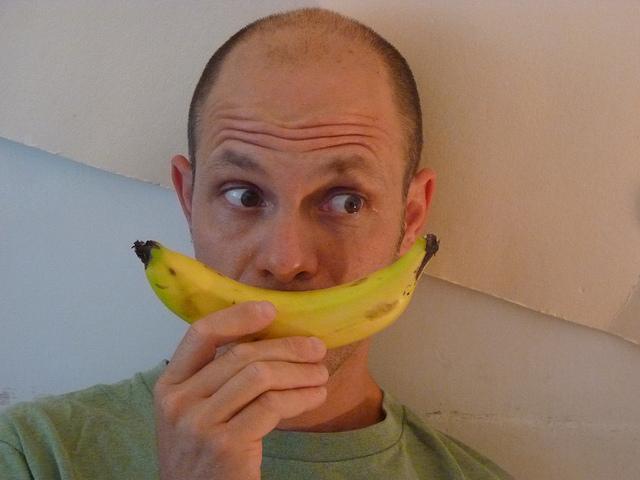How many bananas are there?
Give a very brief answer. 1. 